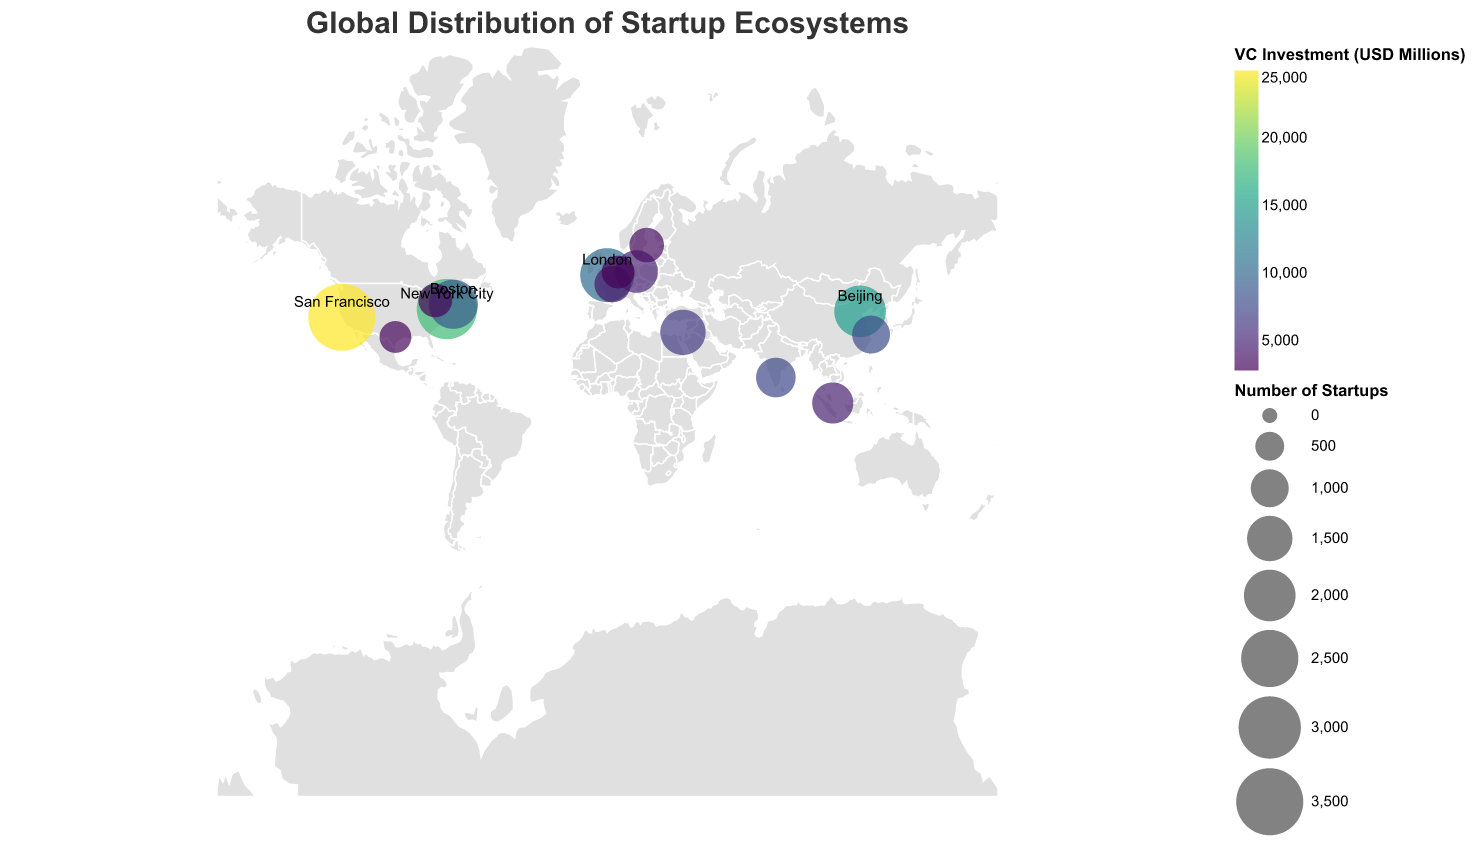What is the title of the figure? The title is typically found at the top of the figure and provides an overview of what the figure represents.
Answer: Global Distribution of Startup Ecosystems Which city has the highest number of startups? By looking at the size of the circles, the largest one represents the highest number of startups. Locating the largest circle on the map shows it is San Francisco.
Answer: San Francisco How many cities are represented in the figure? Each city is represented by a circle. Counting the individual circles gives the total number of cities.
Answer: 15 Which city has received the highest amount of venture capital investment? The color scale represents VC investment. The city with the darker shade corresponds to the highest investment.
Answer: San Francisco What is the average number of startups in the top three cities? The top three cities by startup count are San Francisco (3500), New York City (2800), and London (2200). The average is calculated as (3500 + 2800 + 2200) / 3.
Answer: 2833.33 Which country has the most cities listed in the figure? The countries can be identified by city names. Counting the frequency of each country shows the USA has the most cities listed (San Francisco, New York City, Boston, Austin).
Answer: USA Compare the startup count between Berlin and Singapore. Which city has more startups? Identify the circle sizes for both Berlin and Singapore, and compare the values. Berlin has 1300 startups, while Singapore has 1200.
Answer: Berlin How does the VC investment in Beijing compare to Boston? Look at the color shades for Beijing and Boston. Beijing's VC investment is $15000 million, and Boston's is $9000 million, making Beijing's investment higher.
Answer: Beijing What is the total VC investment in the top 5 cities? The top 5 cities by startup count have VC investments of San Francisco ($25000m), New York City ($18000m), London ($10500m), Beijing ($15000m), and Boston ($9000m). Summing these values gives the total.
Answer: $77500 million Which city has the least number of startups? Identify the smallest circle on the map, which represents the fewest startups. Austin has 650 startups, which is the least among all cities listed.
Answer: Austin 